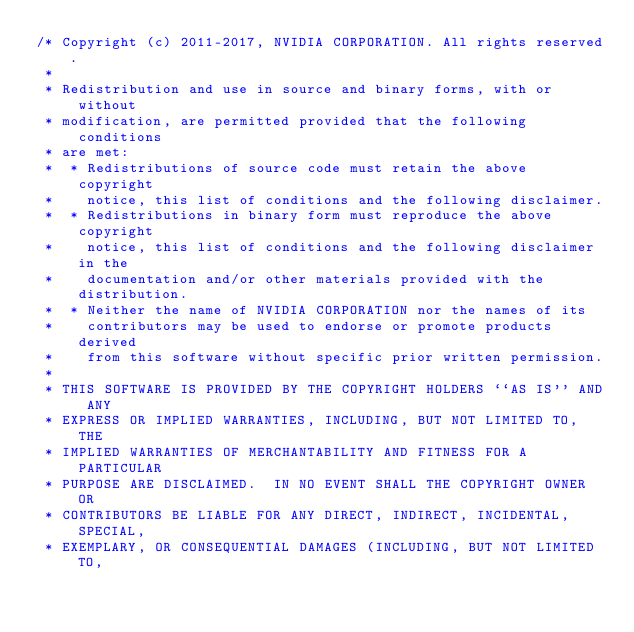Convert code to text. <code><loc_0><loc_0><loc_500><loc_500><_Cuda_>/* Copyright (c) 2011-2017, NVIDIA CORPORATION. All rights reserved.
 *
 * Redistribution and use in source and binary forms, with or without
 * modification, are permitted provided that the following conditions
 * are met:
 *  * Redistributions of source code must retain the above copyright
 *    notice, this list of conditions and the following disclaimer.
 *  * Redistributions in binary form must reproduce the above copyright
 *    notice, this list of conditions and the following disclaimer in the
 *    documentation and/or other materials provided with the distribution.
 *  * Neither the name of NVIDIA CORPORATION nor the names of its
 *    contributors may be used to endorse or promote products derived
 *    from this software without specific prior written permission.
 *
 * THIS SOFTWARE IS PROVIDED BY THE COPYRIGHT HOLDERS ``AS IS'' AND ANY
 * EXPRESS OR IMPLIED WARRANTIES, INCLUDING, BUT NOT LIMITED TO, THE
 * IMPLIED WARRANTIES OF MERCHANTABILITY AND FITNESS FOR A PARTICULAR
 * PURPOSE ARE DISCLAIMED.  IN NO EVENT SHALL THE COPYRIGHT OWNER OR
 * CONTRIBUTORS BE LIABLE FOR ANY DIRECT, INDIRECT, INCIDENTAL, SPECIAL,
 * EXEMPLARY, OR CONSEQUENTIAL DAMAGES (INCLUDING, BUT NOT LIMITED TO,</code> 